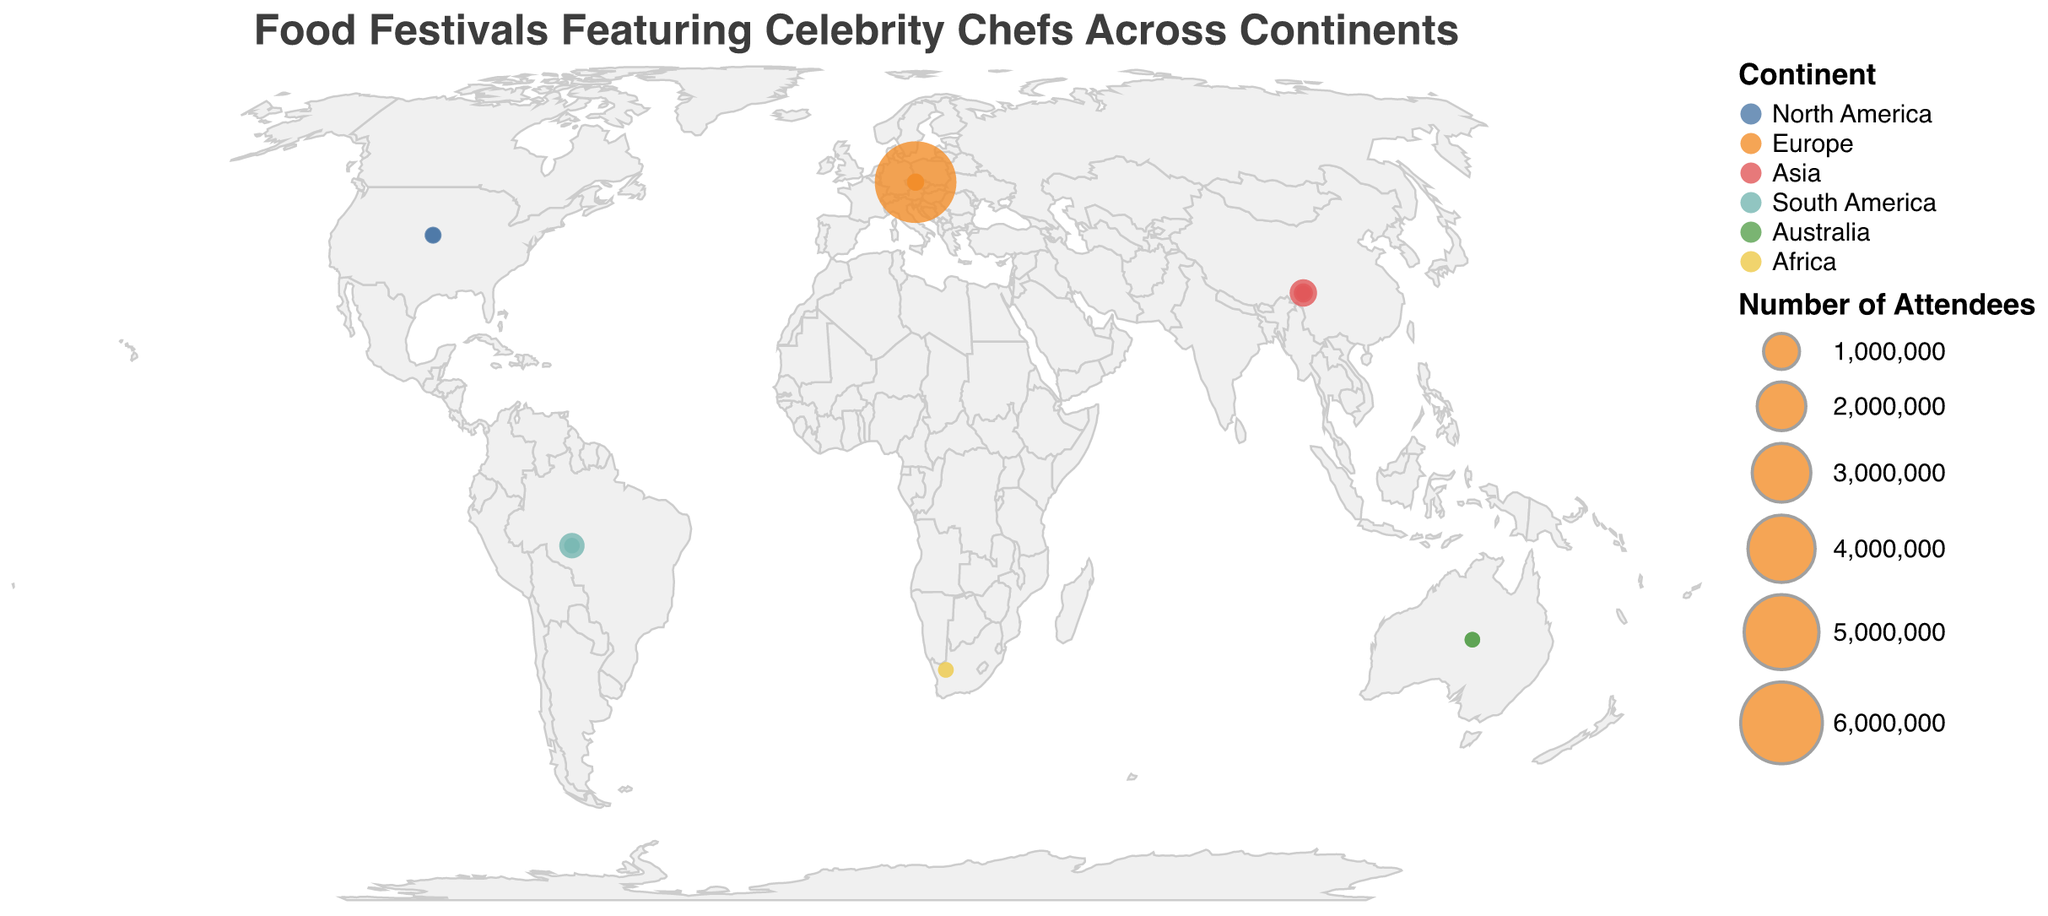Which continent has the highest number of food festival attendees? The bubble size corresponds to the number of attendees, and the largest bubble is located in Europe where Oktoberfest is held with 6,000,000 attendees.
Answer: Europe Which food festival has the highest number of attendees, and who is the celebrity chef associated with it? The largest bubble on the map represents the food festival with the highest number of attendees, which is Oktoberfest in Europe with 6,000,000 attendees, and the celebrity chef associated is Tim Mälzer.
Answer: Oktoberfest, Tim Mälzer Compare the number of attendees for the Tokyo Ramen Show and the Singapore Food Festival. Which one has more attendees and how many more? By comparing the bubble sizes, the Singapore Food Festival has more attendees (500,000) compared to the Tokyo Ramen Show (3,000). The difference is 500,000 - 3,000 = 497,000.
Answer: Singapore Food Festival, 497,000 How many food festivals are represented on the map? By counting the number of bubbles on the map, we can see that there are 14 food festivals in total.
Answer: 14 Identify the food festival with the smallest number of attendees and name the associated celebrity chef. The smallest bubble corresponds to the Tokyo Ramen Show in Asia, which has the smallest number of attendees (3,000), and the celebrity chef is Masaharu Morimoto.
Answer: Tokyo Ramen Show, Masaharu Morimoto What is the average number of attendees across all food festivals in Asia? The food festivals in Asia are Tokyo Ramen Show (3,000), Singapore Food Festival (500,000), and Hong Kong Wine & Dine Festival (140,000). The average is calculated as (3,000 + 500,000 + 140,000) / 3 = 213,000.
Answer: 213,000 Which continent has the most diverse range of celebrity chefs' food festivals? By observing the map, Europe has the most prominent variety with food festivals featuring chefs like Gordon Ramsay, Ferran Adrià, Tim Mälzer, and Jamie Oliver.
Answer: Europe What is the total number of attendees for food festivals in North America? The food festivals in North America and their attendees are Aspen Food & Wine Classic (5,000), South Beach Wine & Food Festival (65,000), and New Orleans Wine & Food Experience (7,000). The total is 5,000 + 65,000 + 7,000 = 77,000.
Answer: 77,000 